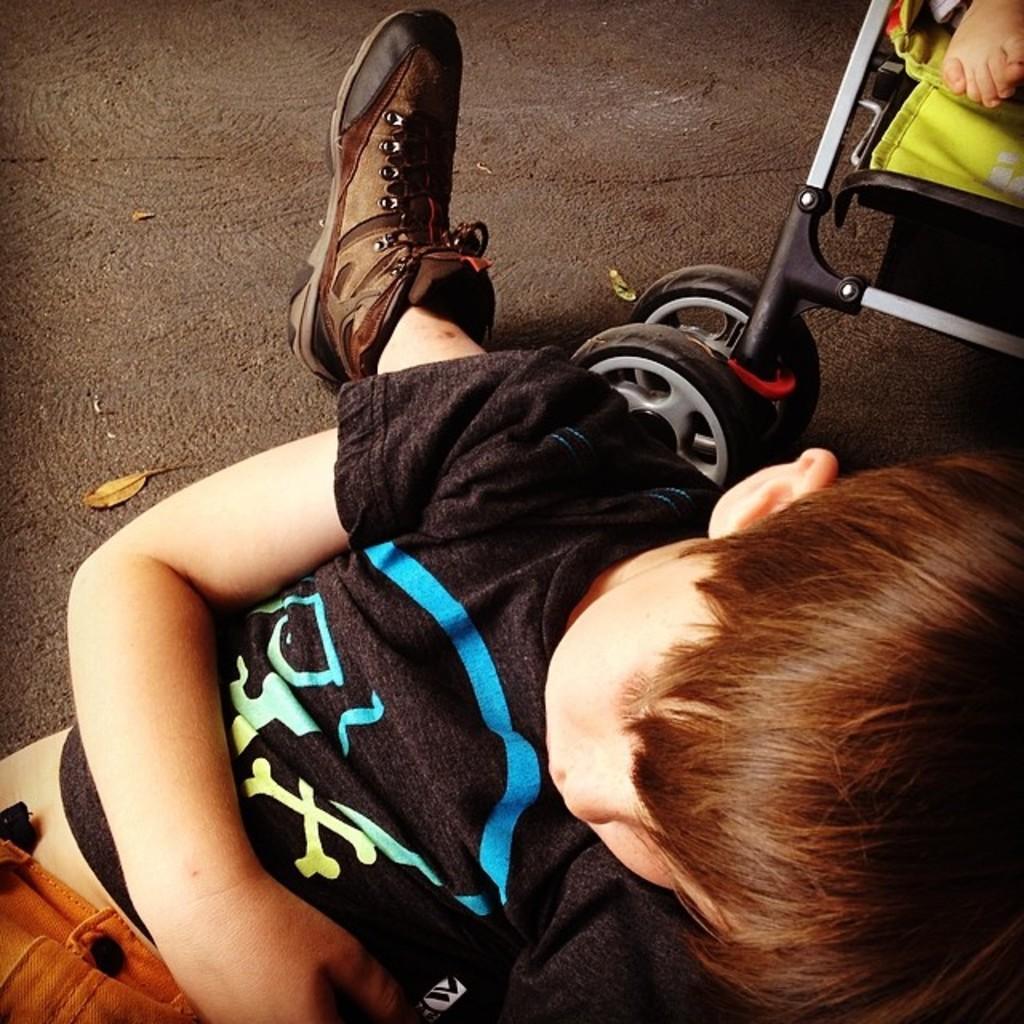Could you give a brief overview of what you see in this image? In this image we can see a boy and a leg of a person. In the top right, we can see a person's leg and a baby trolley. 